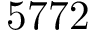<formula> <loc_0><loc_0><loc_500><loc_500>5 7 7 2</formula> 